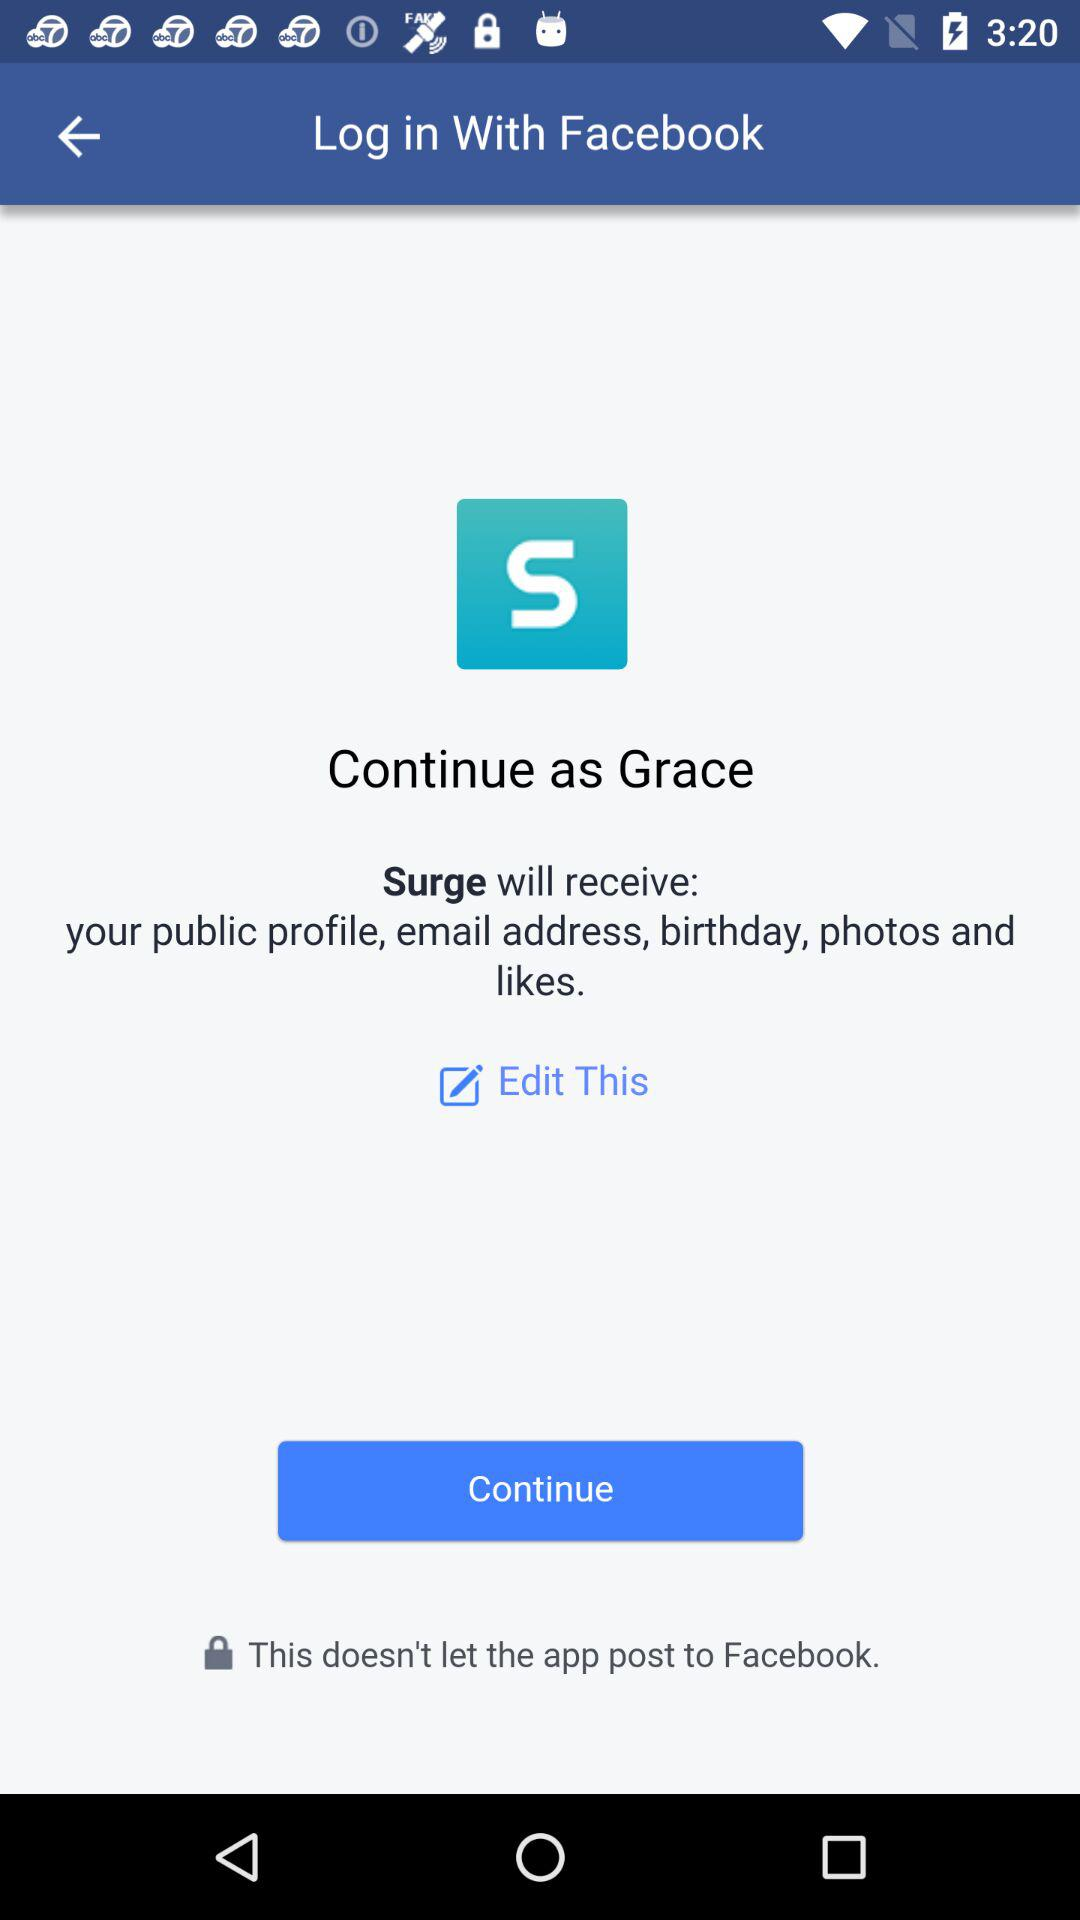What is the login name? The login name is Grace. 